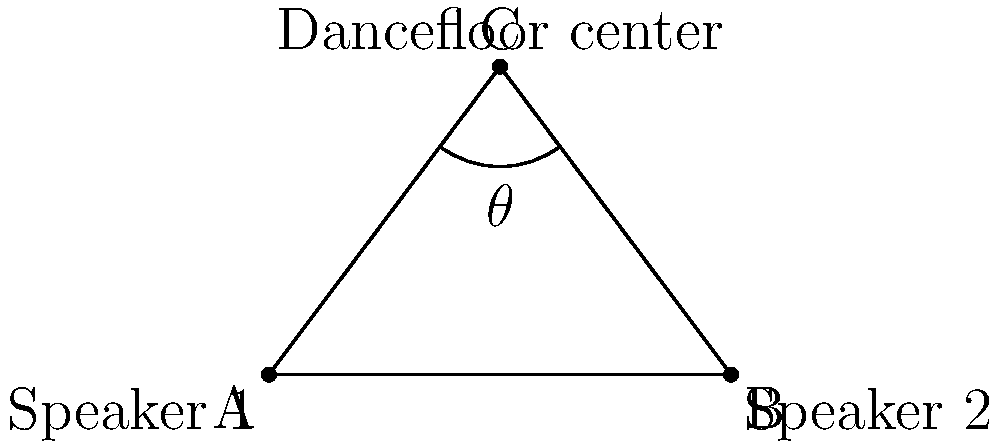In your music club, you've placed two speakers at opposite ends of a 6-meter wide stage (points A and B). The center of the dancefloor (point C) is 4 meters directly in front of the middle of the stage. What is the angle $\theta$ formed by the sound projection from both speakers at the center of the dancefloor? To solve this problem, we'll use the following steps:

1) First, we need to recognize that we have a triangle ABC, where:
   - AB is the stage width (6 meters)
   - C is 4 meters directly in front of the midpoint of AB

2) We can split this into two right triangles by drawing a line from C perpendicular to AB.

3) In one of these right triangles:
   - The base is half of AB, so 3 meters
   - The height is 4 meters

4) We can use the arctangent function to find half of the angle $\theta$:
   
   $\tan(\frac{\theta}{2}) = \frac{\text{opposite}}{\text{adjacent}} = \frac{3}{4}$

5) Therefore:

   $\frac{\theta}{2} = \arctan(\frac{3}{4})$

6) To get the full angle $\theta$, we double this:

   $\theta = 2 \cdot \arctan(\frac{3}{4})$

7) Using a calculator or computer:

   $\theta \approx 2 \cdot 36.87° = 73.74°$

Thus, the angle formed by the sound projection from both speakers at the center of the dancefloor is approximately 73.74°.
Answer: $73.74°$ 